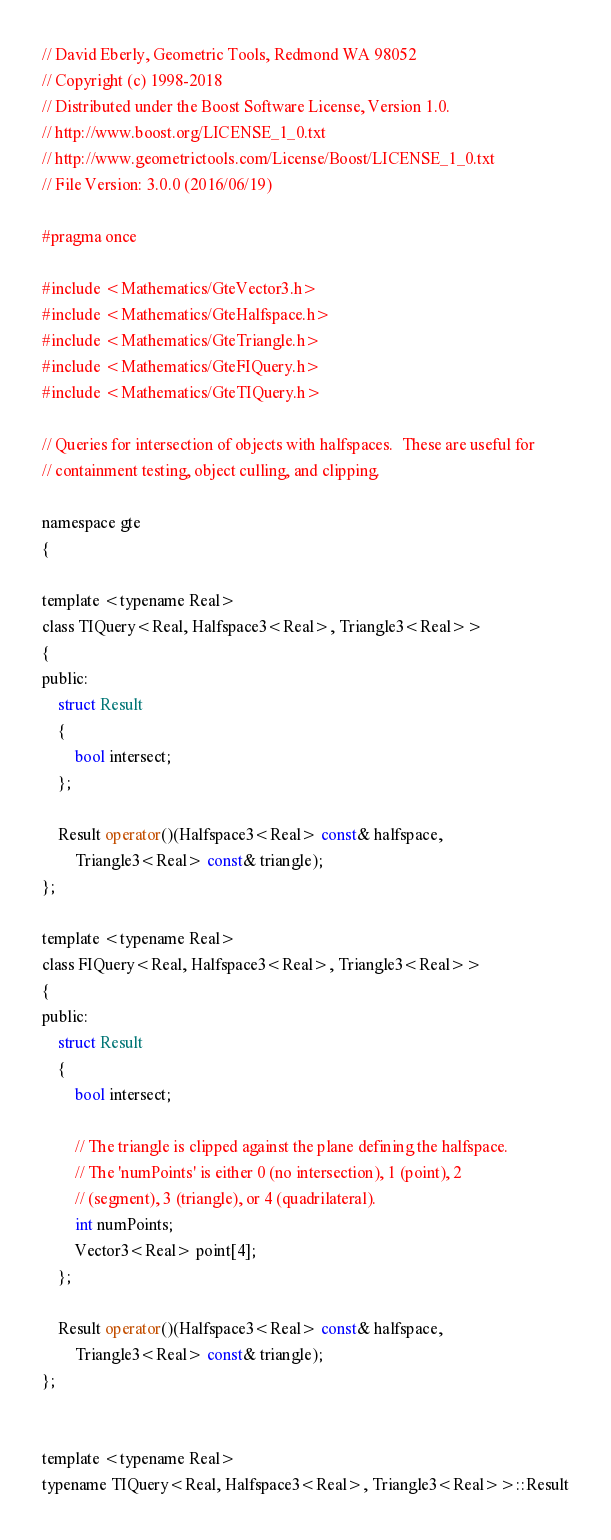<code> <loc_0><loc_0><loc_500><loc_500><_C_>// David Eberly, Geometric Tools, Redmond WA 98052
// Copyright (c) 1998-2018
// Distributed under the Boost Software License, Version 1.0.
// http://www.boost.org/LICENSE_1_0.txt
// http://www.geometrictools.com/License/Boost/LICENSE_1_0.txt
// File Version: 3.0.0 (2016/06/19)

#pragma once

#include <Mathematics/GteVector3.h>
#include <Mathematics/GteHalfspace.h>
#include <Mathematics/GteTriangle.h>
#include <Mathematics/GteFIQuery.h>
#include <Mathematics/GteTIQuery.h>

// Queries for intersection of objects with halfspaces.  These are useful for
// containment testing, object culling, and clipping.

namespace gte
{

template <typename Real>
class TIQuery<Real, Halfspace3<Real>, Triangle3<Real>>
{
public:
    struct Result
    {
        bool intersect;
    };

    Result operator()(Halfspace3<Real> const& halfspace,
        Triangle3<Real> const& triangle);
};

template <typename Real>
class FIQuery<Real, Halfspace3<Real>, Triangle3<Real>>
{
public:
    struct Result
    {
        bool intersect;

        // The triangle is clipped against the plane defining the halfspace.
        // The 'numPoints' is either 0 (no intersection), 1 (point), 2
        // (segment), 3 (triangle), or 4 (quadrilateral).
        int numPoints;
        Vector3<Real> point[4];
    };

    Result operator()(Halfspace3<Real> const& halfspace,
        Triangle3<Real> const& triangle);
};


template <typename Real>
typename TIQuery<Real, Halfspace3<Real>, Triangle3<Real>>::Result</code> 